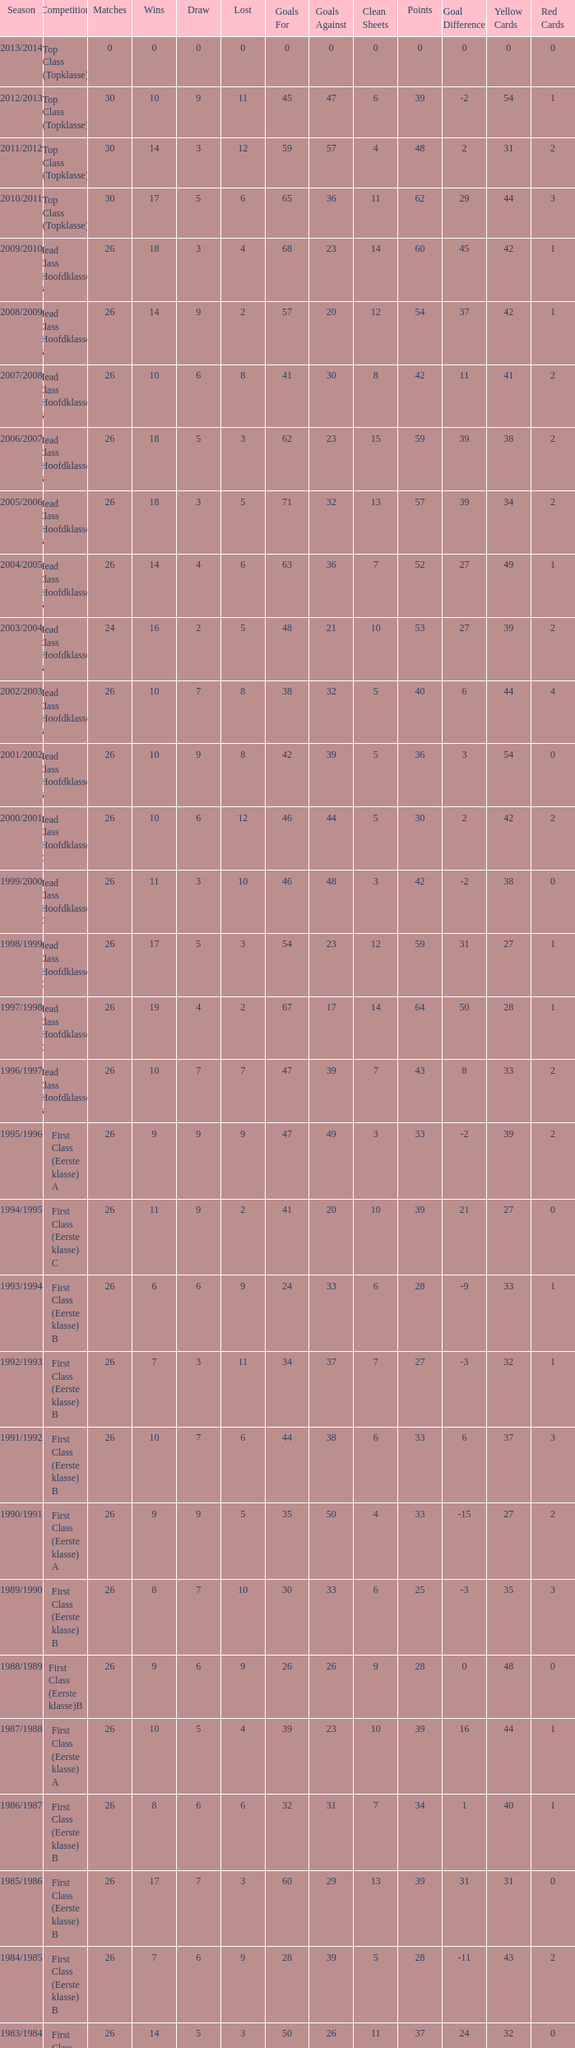What is the total number of matches with a loss less than 5 in the 2008/2009 season and has a draw larger than 9? 0.0. 